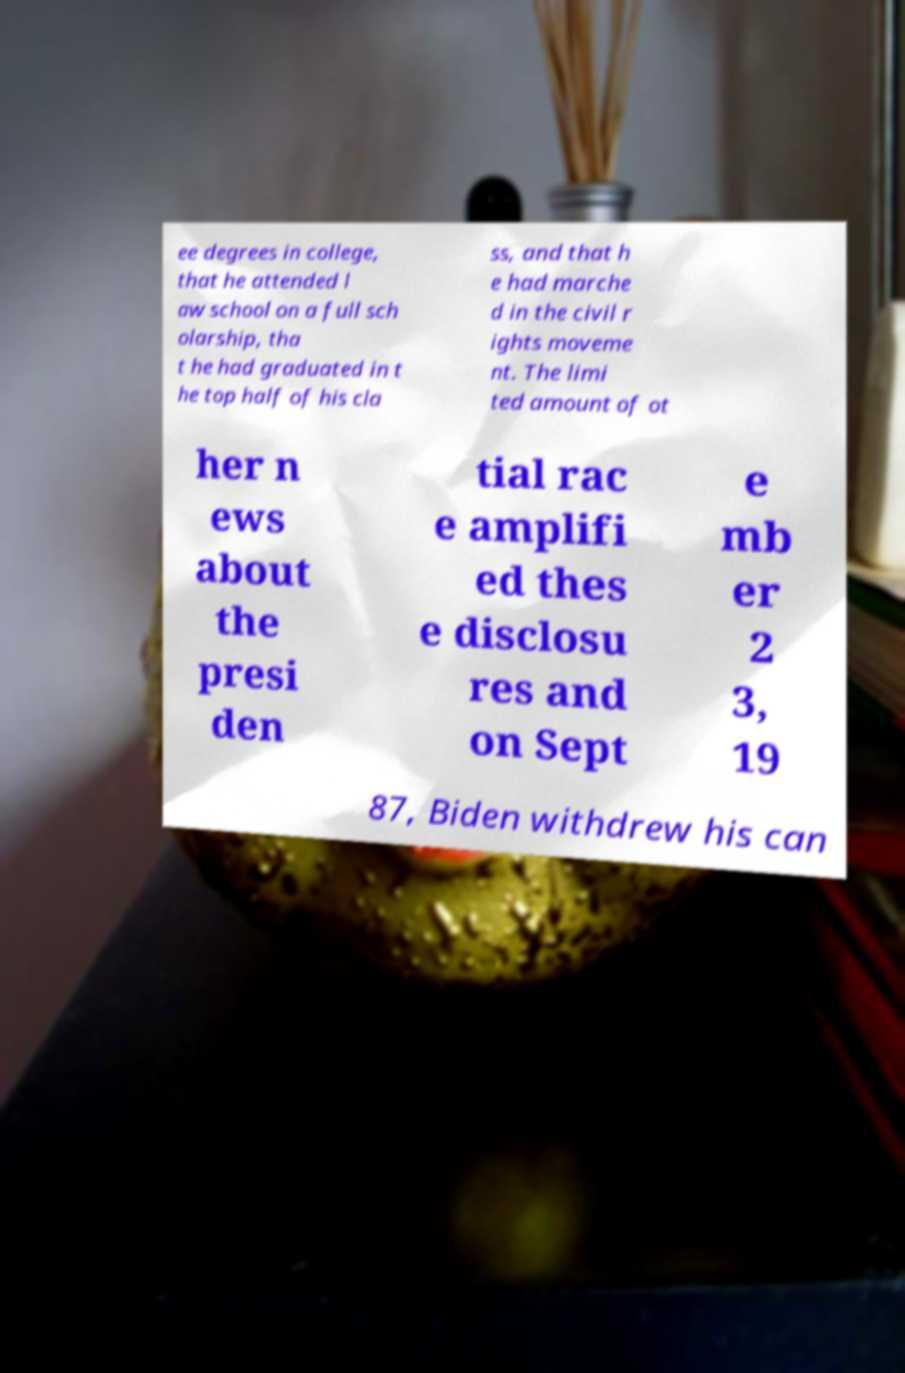Please identify and transcribe the text found in this image. ee degrees in college, that he attended l aw school on a full sch olarship, tha t he had graduated in t he top half of his cla ss, and that h e had marche d in the civil r ights moveme nt. The limi ted amount of ot her n ews about the presi den tial rac e amplifi ed thes e disclosu res and on Sept e mb er 2 3, 19 87, Biden withdrew his can 